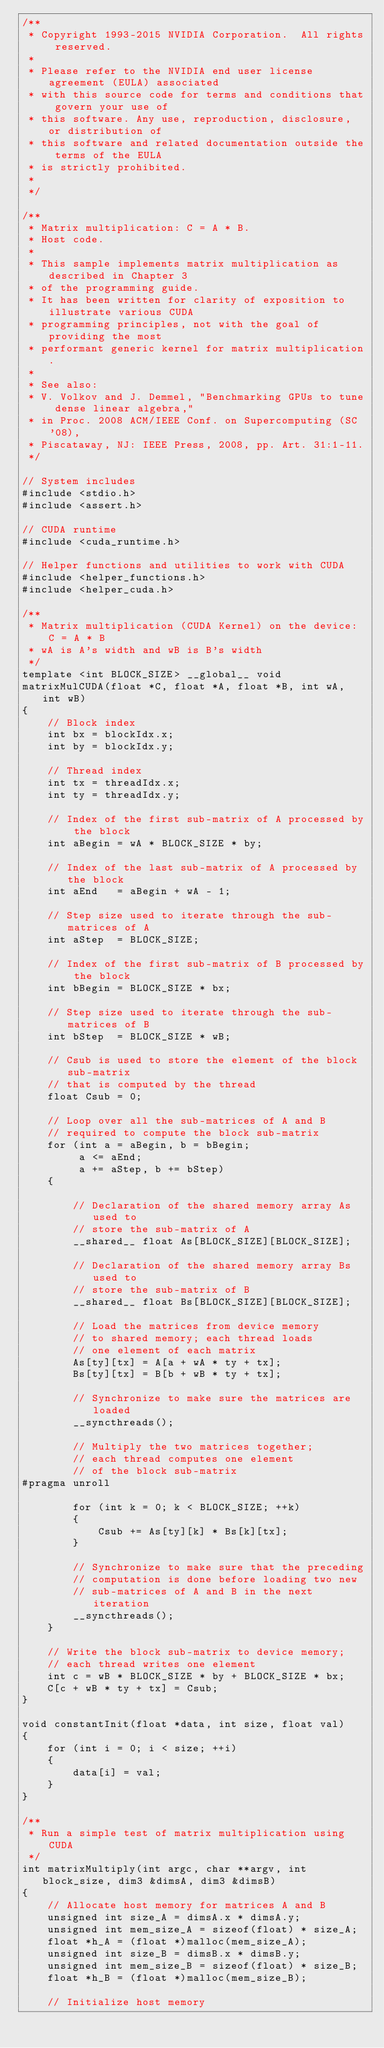<code> <loc_0><loc_0><loc_500><loc_500><_Cuda_>/**
 * Copyright 1993-2015 NVIDIA Corporation.  All rights reserved.
 *
 * Please refer to the NVIDIA end user license agreement (EULA) associated
 * with this source code for terms and conditions that govern your use of
 * this software. Any use, reproduction, disclosure, or distribution of
 * this software and related documentation outside the terms of the EULA
 * is strictly prohibited.
 *
 */

/**
 * Matrix multiplication: C = A * B.
 * Host code.
 *
 * This sample implements matrix multiplication as described in Chapter 3
 * of the programming guide.
 * It has been written for clarity of exposition to illustrate various CUDA
 * programming principles, not with the goal of providing the most
 * performant generic kernel for matrix multiplication.
 *
 * See also:
 * V. Volkov and J. Demmel, "Benchmarking GPUs to tune dense linear algebra,"
 * in Proc. 2008 ACM/IEEE Conf. on Supercomputing (SC '08),
 * Piscataway, NJ: IEEE Press, 2008, pp. Art. 31:1-11.
 */

// System includes
#include <stdio.h>
#include <assert.h>

// CUDA runtime
#include <cuda_runtime.h>

// Helper functions and utilities to work with CUDA
#include <helper_functions.h>
#include <helper_cuda.h>

/**
 * Matrix multiplication (CUDA Kernel) on the device: C = A * B
 * wA is A's width and wB is B's width
 */
template <int BLOCK_SIZE> __global__ void
matrixMulCUDA(float *C, float *A, float *B, int wA, int wB)
{
    // Block index
    int bx = blockIdx.x;
    int by = blockIdx.y;

    // Thread index
    int tx = threadIdx.x;
    int ty = threadIdx.y;

    // Index of the first sub-matrix of A processed by the block
    int aBegin = wA * BLOCK_SIZE * by;

    // Index of the last sub-matrix of A processed by the block
    int aEnd   = aBegin + wA - 1;

    // Step size used to iterate through the sub-matrices of A
    int aStep  = BLOCK_SIZE;

    // Index of the first sub-matrix of B processed by the block
    int bBegin = BLOCK_SIZE * bx;

    // Step size used to iterate through the sub-matrices of B
    int bStep  = BLOCK_SIZE * wB;

    // Csub is used to store the element of the block sub-matrix
    // that is computed by the thread
    float Csub = 0;

    // Loop over all the sub-matrices of A and B
    // required to compute the block sub-matrix
    for (int a = aBegin, b = bBegin;
         a <= aEnd;
         a += aStep, b += bStep)
    {

        // Declaration of the shared memory array As used to
        // store the sub-matrix of A
        __shared__ float As[BLOCK_SIZE][BLOCK_SIZE];

        // Declaration of the shared memory array Bs used to
        // store the sub-matrix of B
        __shared__ float Bs[BLOCK_SIZE][BLOCK_SIZE];

        // Load the matrices from device memory
        // to shared memory; each thread loads
        // one element of each matrix
        As[ty][tx] = A[a + wA * ty + tx];
        Bs[ty][tx] = B[b + wB * ty + tx];

        // Synchronize to make sure the matrices are loaded
        __syncthreads();

        // Multiply the two matrices together;
        // each thread computes one element
        // of the block sub-matrix
#pragma unroll

        for (int k = 0; k < BLOCK_SIZE; ++k)
        {
            Csub += As[ty][k] * Bs[k][tx];
        }

        // Synchronize to make sure that the preceding
        // computation is done before loading two new
        // sub-matrices of A and B in the next iteration
        __syncthreads();
    }

    // Write the block sub-matrix to device memory;
    // each thread writes one element
    int c = wB * BLOCK_SIZE * by + BLOCK_SIZE * bx;
    C[c + wB * ty + tx] = Csub;
}

void constantInit(float *data, int size, float val)
{
    for (int i = 0; i < size; ++i)
    {
        data[i] = val;
    }
}

/**
 * Run a simple test of matrix multiplication using CUDA
 */
int matrixMultiply(int argc, char **argv, int block_size, dim3 &dimsA, dim3 &dimsB)
{
    // Allocate host memory for matrices A and B
    unsigned int size_A = dimsA.x * dimsA.y;
    unsigned int mem_size_A = sizeof(float) * size_A;
    float *h_A = (float *)malloc(mem_size_A);
    unsigned int size_B = dimsB.x * dimsB.y;
    unsigned int mem_size_B = sizeof(float) * size_B;
    float *h_B = (float *)malloc(mem_size_B);

    // Initialize host memory</code> 